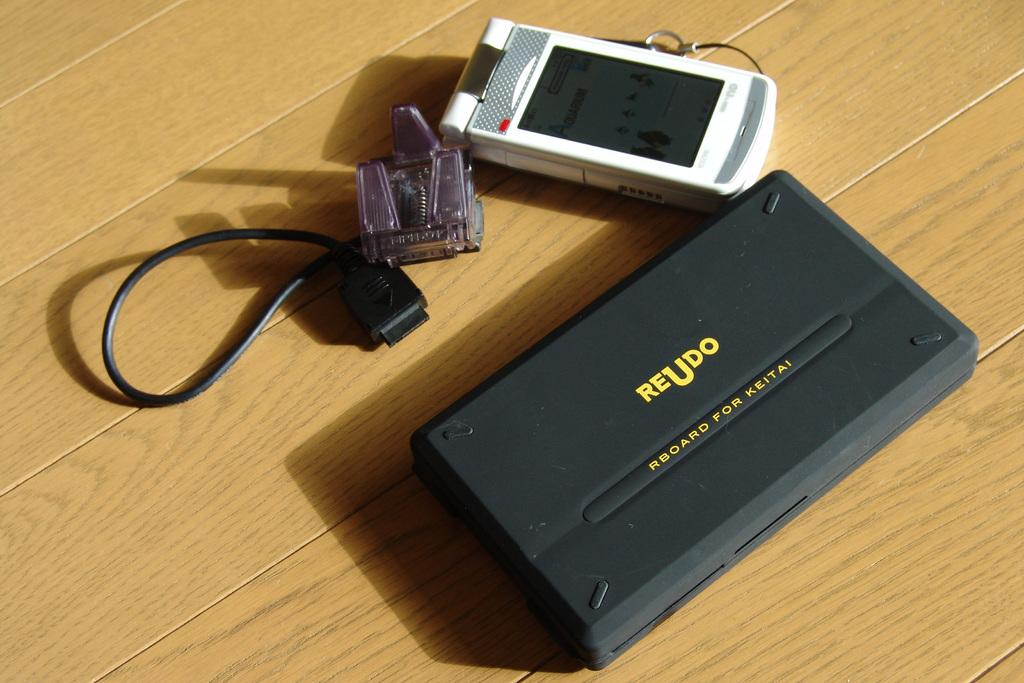<image>
Present a compact description of the photo's key features. two devices and a cord are laying together with the Reudo one being grey 